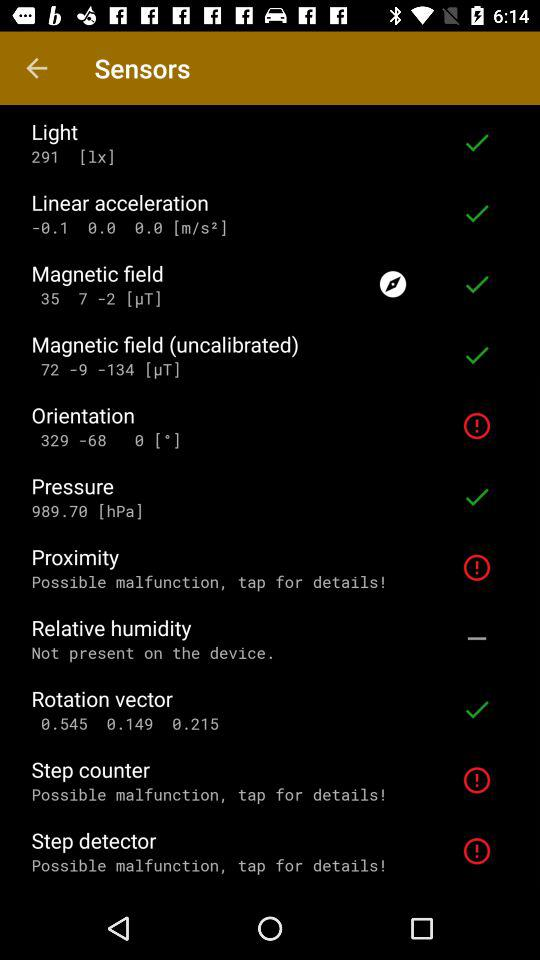What is the unit of linear acceleration? The unit of linear acceleration is m/s². 